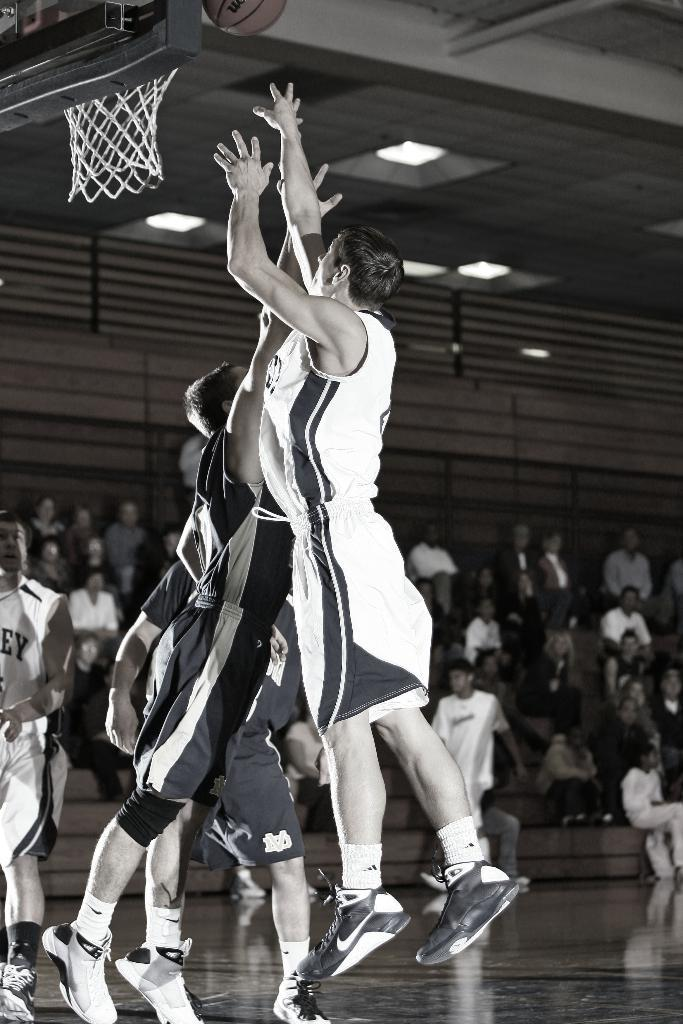What are the people in the image doing? There is a group of people playing a game in the image. What type of game are they playing? The presence of a basketball and a basketball hoop suggests that they are playing basketball. Can you describe the people sitting in the background of the image? There are people sitting in the background of the image, but their specific actions or characteristics are not mentioned in the provided facts. What is the main object in the game they are playing? The main object in the game they are playing is the basketball. How many spiders are crawling on the basketball hoop in the image? There are no spiders present in the image; it features a group of people playing basketball with a basketball hoop. Can you describe the faucet used by the players to wash their hands after the game? There is no mention of a faucet in the image or the provided facts. --- Facts: 1. There is a person holding a camera in the image. 2. The person is standing on a bridge. 3. There is a river below the bridge. 4. The sky is visible in the image. Absurd Topics: elephant, umbrella, dance Conversation: What is the person in the image holding? The person in the image is holding a camera. Where is the person standing in the image? The person is standing on a bridge. What can be seen below the bridge? There is a river below the bridge. What is visible in the background of the image? The sky is visible in the image. Reasoning: Let's think step by step in order to produce the conversation. We start by identifying the main subject in the image, which is the person holding a camera. Then, we use the provided facts to determine the person's location, which is on a bridge. Next, we mention the river below the bridge and the sky visible in the background. Each question is designed to elicit a specific detail about the image that is known from the provided facts. Absurd Question/Answer: Can you describe the elephant walking under the bridge in the image? There is no elephant present in the image; it features a person holding a camera while standing on a bridge with a river below. What type of dance is the person performing on the bridge in the image? There is no indication in the image or the provided facts that the person is dancing. 